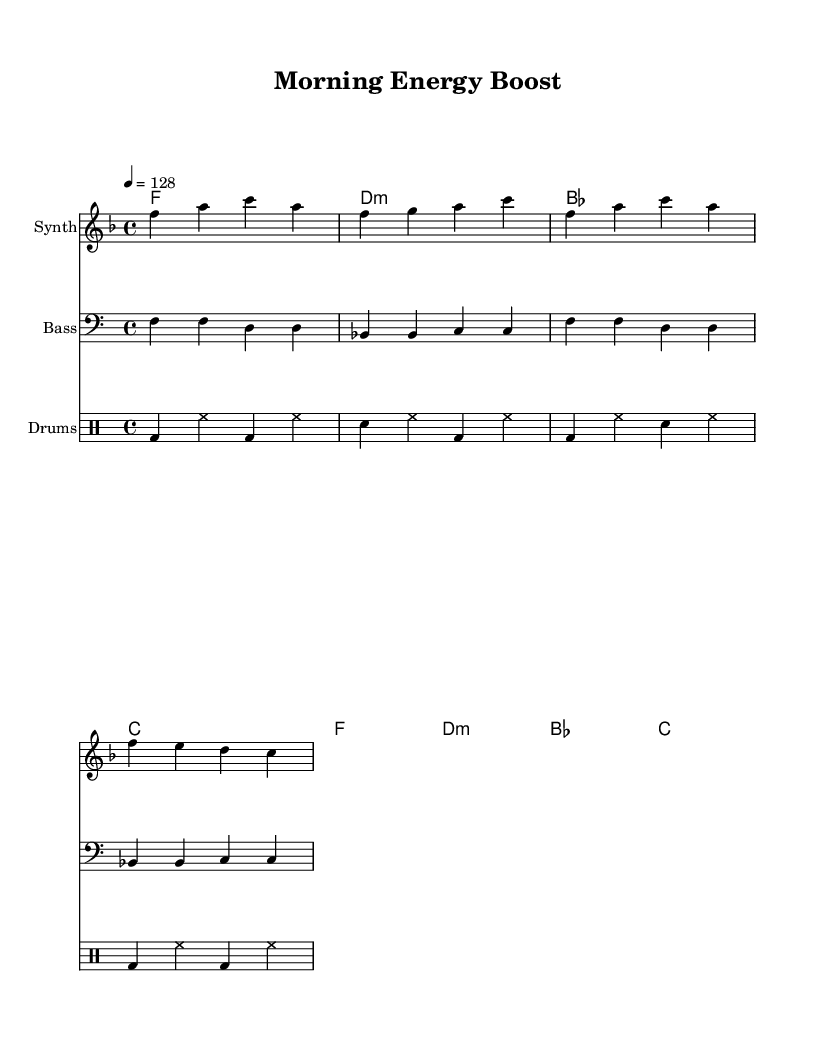What is the key signature of this music? The key signature shows one flat, indicating the music is in F major.
Answer: F major What is the time signature of this piece? The time signature is indicated as 4/4, meaning there are four beats per measure.
Answer: 4/4 What is the tempo marking in the score? The tempo marking shows "4 = 128," meaning each quarter note is played at 128 beats per minute.
Answer: 128 How many measures are there in the melody? Counting the measures in the melody, there are four measures total.
Answer: 4 What are the first two notes of the melody? The melody starts with F and A, as shown in the first measure.
Answer: F, A Identify the chord that appears after the first measure. The first chord shown after the first measure is D minor, denoted by "d:m".
Answer: D minor What type of rhythm pattern is primarily used in the drums section? The rhythm pattern consists of alternating bass drum, hi-hat, and snare hits, creating a driving beat typical of house music.
Answer: Driving beat 